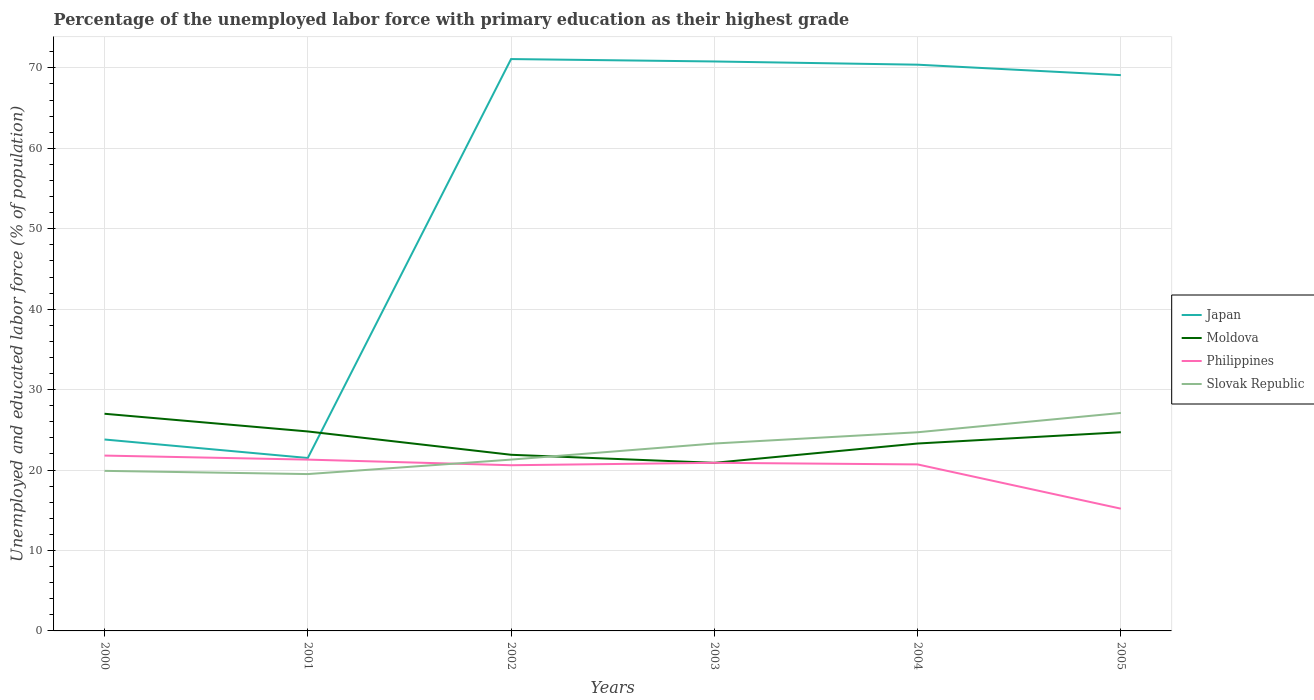How many different coloured lines are there?
Provide a succinct answer. 4. Does the line corresponding to Japan intersect with the line corresponding to Slovak Republic?
Provide a succinct answer. No. What is the total percentage of the unemployed labor force with primary education in Moldova in the graph?
Provide a short and direct response. 6.1. What is the difference between the highest and the second highest percentage of the unemployed labor force with primary education in Moldova?
Make the answer very short. 6.1. What is the difference between the highest and the lowest percentage of the unemployed labor force with primary education in Japan?
Offer a terse response. 4. Is the percentage of the unemployed labor force with primary education in Slovak Republic strictly greater than the percentage of the unemployed labor force with primary education in Moldova over the years?
Ensure brevity in your answer.  No. How many lines are there?
Give a very brief answer. 4. What is the difference between two consecutive major ticks on the Y-axis?
Give a very brief answer. 10. What is the title of the graph?
Offer a very short reply. Percentage of the unemployed labor force with primary education as their highest grade. What is the label or title of the X-axis?
Provide a succinct answer. Years. What is the label or title of the Y-axis?
Your answer should be very brief. Unemployed and educated labor force (% of population). What is the Unemployed and educated labor force (% of population) in Japan in 2000?
Your answer should be compact. 23.8. What is the Unemployed and educated labor force (% of population) of Moldova in 2000?
Keep it short and to the point. 27. What is the Unemployed and educated labor force (% of population) of Philippines in 2000?
Give a very brief answer. 21.8. What is the Unemployed and educated labor force (% of population) in Slovak Republic in 2000?
Offer a very short reply. 19.9. What is the Unemployed and educated labor force (% of population) in Moldova in 2001?
Offer a terse response. 24.8. What is the Unemployed and educated labor force (% of population) of Philippines in 2001?
Keep it short and to the point. 21.3. What is the Unemployed and educated labor force (% of population) of Slovak Republic in 2001?
Offer a terse response. 19.5. What is the Unemployed and educated labor force (% of population) in Japan in 2002?
Provide a succinct answer. 71.1. What is the Unemployed and educated labor force (% of population) in Moldova in 2002?
Make the answer very short. 21.9. What is the Unemployed and educated labor force (% of population) in Philippines in 2002?
Your answer should be compact. 20.6. What is the Unemployed and educated labor force (% of population) of Slovak Republic in 2002?
Offer a terse response. 21.3. What is the Unemployed and educated labor force (% of population) in Japan in 2003?
Ensure brevity in your answer.  70.8. What is the Unemployed and educated labor force (% of population) of Moldova in 2003?
Your response must be concise. 20.9. What is the Unemployed and educated labor force (% of population) in Philippines in 2003?
Make the answer very short. 20.9. What is the Unemployed and educated labor force (% of population) in Slovak Republic in 2003?
Your response must be concise. 23.3. What is the Unemployed and educated labor force (% of population) of Japan in 2004?
Your answer should be compact. 70.4. What is the Unemployed and educated labor force (% of population) of Moldova in 2004?
Make the answer very short. 23.3. What is the Unemployed and educated labor force (% of population) in Philippines in 2004?
Make the answer very short. 20.7. What is the Unemployed and educated labor force (% of population) in Slovak Republic in 2004?
Provide a succinct answer. 24.7. What is the Unemployed and educated labor force (% of population) of Japan in 2005?
Your response must be concise. 69.1. What is the Unemployed and educated labor force (% of population) in Moldova in 2005?
Give a very brief answer. 24.7. What is the Unemployed and educated labor force (% of population) in Philippines in 2005?
Give a very brief answer. 15.2. What is the Unemployed and educated labor force (% of population) in Slovak Republic in 2005?
Make the answer very short. 27.1. Across all years, what is the maximum Unemployed and educated labor force (% of population) in Japan?
Your answer should be compact. 71.1. Across all years, what is the maximum Unemployed and educated labor force (% of population) in Philippines?
Keep it short and to the point. 21.8. Across all years, what is the maximum Unemployed and educated labor force (% of population) in Slovak Republic?
Offer a very short reply. 27.1. Across all years, what is the minimum Unemployed and educated labor force (% of population) in Japan?
Ensure brevity in your answer.  21.5. Across all years, what is the minimum Unemployed and educated labor force (% of population) in Moldova?
Provide a succinct answer. 20.9. Across all years, what is the minimum Unemployed and educated labor force (% of population) in Philippines?
Your response must be concise. 15.2. What is the total Unemployed and educated labor force (% of population) in Japan in the graph?
Your answer should be very brief. 326.7. What is the total Unemployed and educated labor force (% of population) in Moldova in the graph?
Your answer should be very brief. 142.6. What is the total Unemployed and educated labor force (% of population) of Philippines in the graph?
Offer a terse response. 120.5. What is the total Unemployed and educated labor force (% of population) in Slovak Republic in the graph?
Provide a succinct answer. 135.8. What is the difference between the Unemployed and educated labor force (% of population) of Moldova in 2000 and that in 2001?
Offer a very short reply. 2.2. What is the difference between the Unemployed and educated labor force (% of population) of Philippines in 2000 and that in 2001?
Ensure brevity in your answer.  0.5. What is the difference between the Unemployed and educated labor force (% of population) of Japan in 2000 and that in 2002?
Keep it short and to the point. -47.3. What is the difference between the Unemployed and educated labor force (% of population) in Slovak Republic in 2000 and that in 2002?
Keep it short and to the point. -1.4. What is the difference between the Unemployed and educated labor force (% of population) in Japan in 2000 and that in 2003?
Provide a short and direct response. -47. What is the difference between the Unemployed and educated labor force (% of population) of Slovak Republic in 2000 and that in 2003?
Offer a very short reply. -3.4. What is the difference between the Unemployed and educated labor force (% of population) of Japan in 2000 and that in 2004?
Ensure brevity in your answer.  -46.6. What is the difference between the Unemployed and educated labor force (% of population) in Philippines in 2000 and that in 2004?
Provide a succinct answer. 1.1. What is the difference between the Unemployed and educated labor force (% of population) of Slovak Republic in 2000 and that in 2004?
Your answer should be compact. -4.8. What is the difference between the Unemployed and educated labor force (% of population) of Japan in 2000 and that in 2005?
Give a very brief answer. -45.3. What is the difference between the Unemployed and educated labor force (% of population) of Slovak Republic in 2000 and that in 2005?
Provide a succinct answer. -7.2. What is the difference between the Unemployed and educated labor force (% of population) of Japan in 2001 and that in 2002?
Give a very brief answer. -49.6. What is the difference between the Unemployed and educated labor force (% of population) in Japan in 2001 and that in 2003?
Provide a succinct answer. -49.3. What is the difference between the Unemployed and educated labor force (% of population) in Philippines in 2001 and that in 2003?
Keep it short and to the point. 0.4. What is the difference between the Unemployed and educated labor force (% of population) in Slovak Republic in 2001 and that in 2003?
Your response must be concise. -3.8. What is the difference between the Unemployed and educated labor force (% of population) of Japan in 2001 and that in 2004?
Provide a short and direct response. -48.9. What is the difference between the Unemployed and educated labor force (% of population) in Philippines in 2001 and that in 2004?
Keep it short and to the point. 0.6. What is the difference between the Unemployed and educated labor force (% of population) of Japan in 2001 and that in 2005?
Offer a terse response. -47.6. What is the difference between the Unemployed and educated labor force (% of population) in Moldova in 2001 and that in 2005?
Offer a terse response. 0.1. What is the difference between the Unemployed and educated labor force (% of population) in Philippines in 2001 and that in 2005?
Provide a short and direct response. 6.1. What is the difference between the Unemployed and educated labor force (% of population) of Japan in 2002 and that in 2003?
Your answer should be compact. 0.3. What is the difference between the Unemployed and educated labor force (% of population) of Slovak Republic in 2002 and that in 2003?
Your response must be concise. -2. What is the difference between the Unemployed and educated labor force (% of population) in Moldova in 2002 and that in 2004?
Offer a very short reply. -1.4. What is the difference between the Unemployed and educated labor force (% of population) in Slovak Republic in 2002 and that in 2004?
Provide a short and direct response. -3.4. What is the difference between the Unemployed and educated labor force (% of population) of Moldova in 2002 and that in 2005?
Provide a short and direct response. -2.8. What is the difference between the Unemployed and educated labor force (% of population) of Slovak Republic in 2002 and that in 2005?
Make the answer very short. -5.8. What is the difference between the Unemployed and educated labor force (% of population) of Japan in 2003 and that in 2004?
Your response must be concise. 0.4. What is the difference between the Unemployed and educated labor force (% of population) in Philippines in 2003 and that in 2004?
Make the answer very short. 0.2. What is the difference between the Unemployed and educated labor force (% of population) in Slovak Republic in 2003 and that in 2004?
Keep it short and to the point. -1.4. What is the difference between the Unemployed and educated labor force (% of population) of Japan in 2003 and that in 2005?
Provide a succinct answer. 1.7. What is the difference between the Unemployed and educated labor force (% of population) in Moldova in 2003 and that in 2005?
Your answer should be compact. -3.8. What is the difference between the Unemployed and educated labor force (% of population) in Philippines in 2003 and that in 2005?
Offer a very short reply. 5.7. What is the difference between the Unemployed and educated labor force (% of population) of Slovak Republic in 2003 and that in 2005?
Offer a very short reply. -3.8. What is the difference between the Unemployed and educated labor force (% of population) in Japan in 2004 and that in 2005?
Keep it short and to the point. 1.3. What is the difference between the Unemployed and educated labor force (% of population) in Slovak Republic in 2004 and that in 2005?
Offer a terse response. -2.4. What is the difference between the Unemployed and educated labor force (% of population) in Japan in 2000 and the Unemployed and educated labor force (% of population) in Philippines in 2001?
Make the answer very short. 2.5. What is the difference between the Unemployed and educated labor force (% of population) of Moldova in 2000 and the Unemployed and educated labor force (% of population) of Philippines in 2001?
Offer a very short reply. 5.7. What is the difference between the Unemployed and educated labor force (% of population) of Japan in 2000 and the Unemployed and educated labor force (% of population) of Moldova in 2002?
Your answer should be very brief. 1.9. What is the difference between the Unemployed and educated labor force (% of population) of Japan in 2000 and the Unemployed and educated labor force (% of population) of Philippines in 2002?
Ensure brevity in your answer.  3.2. What is the difference between the Unemployed and educated labor force (% of population) in Philippines in 2000 and the Unemployed and educated labor force (% of population) in Slovak Republic in 2002?
Provide a succinct answer. 0.5. What is the difference between the Unemployed and educated labor force (% of population) of Japan in 2000 and the Unemployed and educated labor force (% of population) of Moldova in 2003?
Your answer should be very brief. 2.9. What is the difference between the Unemployed and educated labor force (% of population) in Japan in 2000 and the Unemployed and educated labor force (% of population) in Slovak Republic in 2003?
Offer a very short reply. 0.5. What is the difference between the Unemployed and educated labor force (% of population) of Moldova in 2000 and the Unemployed and educated labor force (% of population) of Slovak Republic in 2003?
Offer a very short reply. 3.7. What is the difference between the Unemployed and educated labor force (% of population) in Japan in 2000 and the Unemployed and educated labor force (% of population) in Moldova in 2004?
Make the answer very short. 0.5. What is the difference between the Unemployed and educated labor force (% of population) in Japan in 2000 and the Unemployed and educated labor force (% of population) in Slovak Republic in 2004?
Your answer should be compact. -0.9. What is the difference between the Unemployed and educated labor force (% of population) in Moldova in 2000 and the Unemployed and educated labor force (% of population) in Slovak Republic in 2004?
Make the answer very short. 2.3. What is the difference between the Unemployed and educated labor force (% of population) of Japan in 2000 and the Unemployed and educated labor force (% of population) of Moldova in 2005?
Your response must be concise. -0.9. What is the difference between the Unemployed and educated labor force (% of population) in Japan in 2000 and the Unemployed and educated labor force (% of population) in Philippines in 2005?
Your answer should be very brief. 8.6. What is the difference between the Unemployed and educated labor force (% of population) in Moldova in 2000 and the Unemployed and educated labor force (% of population) in Philippines in 2005?
Your answer should be very brief. 11.8. What is the difference between the Unemployed and educated labor force (% of population) of Japan in 2001 and the Unemployed and educated labor force (% of population) of Moldova in 2002?
Your answer should be very brief. -0.4. What is the difference between the Unemployed and educated labor force (% of population) of Japan in 2001 and the Unemployed and educated labor force (% of population) of Philippines in 2002?
Make the answer very short. 0.9. What is the difference between the Unemployed and educated labor force (% of population) of Japan in 2001 and the Unemployed and educated labor force (% of population) of Slovak Republic in 2002?
Provide a short and direct response. 0.2. What is the difference between the Unemployed and educated labor force (% of population) of Moldova in 2001 and the Unemployed and educated labor force (% of population) of Philippines in 2002?
Ensure brevity in your answer.  4.2. What is the difference between the Unemployed and educated labor force (% of population) of Japan in 2001 and the Unemployed and educated labor force (% of population) of Moldova in 2003?
Your answer should be compact. 0.6. What is the difference between the Unemployed and educated labor force (% of population) in Japan in 2001 and the Unemployed and educated labor force (% of population) in Philippines in 2003?
Ensure brevity in your answer.  0.6. What is the difference between the Unemployed and educated labor force (% of population) of Japan in 2001 and the Unemployed and educated labor force (% of population) of Slovak Republic in 2003?
Your answer should be compact. -1.8. What is the difference between the Unemployed and educated labor force (% of population) of Moldova in 2001 and the Unemployed and educated labor force (% of population) of Philippines in 2003?
Offer a terse response. 3.9. What is the difference between the Unemployed and educated labor force (% of population) of Japan in 2001 and the Unemployed and educated labor force (% of population) of Philippines in 2004?
Your answer should be very brief. 0.8. What is the difference between the Unemployed and educated labor force (% of population) in Japan in 2001 and the Unemployed and educated labor force (% of population) in Moldova in 2005?
Provide a succinct answer. -3.2. What is the difference between the Unemployed and educated labor force (% of population) of Japan in 2001 and the Unemployed and educated labor force (% of population) of Philippines in 2005?
Offer a terse response. 6.3. What is the difference between the Unemployed and educated labor force (% of population) in Japan in 2001 and the Unemployed and educated labor force (% of population) in Slovak Republic in 2005?
Give a very brief answer. -5.6. What is the difference between the Unemployed and educated labor force (% of population) in Moldova in 2001 and the Unemployed and educated labor force (% of population) in Philippines in 2005?
Make the answer very short. 9.6. What is the difference between the Unemployed and educated labor force (% of population) of Moldova in 2001 and the Unemployed and educated labor force (% of population) of Slovak Republic in 2005?
Offer a terse response. -2.3. What is the difference between the Unemployed and educated labor force (% of population) of Philippines in 2001 and the Unemployed and educated labor force (% of population) of Slovak Republic in 2005?
Make the answer very short. -5.8. What is the difference between the Unemployed and educated labor force (% of population) of Japan in 2002 and the Unemployed and educated labor force (% of population) of Moldova in 2003?
Your answer should be compact. 50.2. What is the difference between the Unemployed and educated labor force (% of population) of Japan in 2002 and the Unemployed and educated labor force (% of population) of Philippines in 2003?
Make the answer very short. 50.2. What is the difference between the Unemployed and educated labor force (% of population) of Japan in 2002 and the Unemployed and educated labor force (% of population) of Slovak Republic in 2003?
Your answer should be very brief. 47.8. What is the difference between the Unemployed and educated labor force (% of population) in Japan in 2002 and the Unemployed and educated labor force (% of population) in Moldova in 2004?
Offer a terse response. 47.8. What is the difference between the Unemployed and educated labor force (% of population) in Japan in 2002 and the Unemployed and educated labor force (% of population) in Philippines in 2004?
Provide a succinct answer. 50.4. What is the difference between the Unemployed and educated labor force (% of population) in Japan in 2002 and the Unemployed and educated labor force (% of population) in Slovak Republic in 2004?
Make the answer very short. 46.4. What is the difference between the Unemployed and educated labor force (% of population) of Moldova in 2002 and the Unemployed and educated labor force (% of population) of Philippines in 2004?
Make the answer very short. 1.2. What is the difference between the Unemployed and educated labor force (% of population) of Moldova in 2002 and the Unemployed and educated labor force (% of population) of Slovak Republic in 2004?
Provide a succinct answer. -2.8. What is the difference between the Unemployed and educated labor force (% of population) in Philippines in 2002 and the Unemployed and educated labor force (% of population) in Slovak Republic in 2004?
Your answer should be compact. -4.1. What is the difference between the Unemployed and educated labor force (% of population) of Japan in 2002 and the Unemployed and educated labor force (% of population) of Moldova in 2005?
Make the answer very short. 46.4. What is the difference between the Unemployed and educated labor force (% of population) in Japan in 2002 and the Unemployed and educated labor force (% of population) in Philippines in 2005?
Give a very brief answer. 55.9. What is the difference between the Unemployed and educated labor force (% of population) of Moldova in 2002 and the Unemployed and educated labor force (% of population) of Slovak Republic in 2005?
Your answer should be very brief. -5.2. What is the difference between the Unemployed and educated labor force (% of population) of Philippines in 2002 and the Unemployed and educated labor force (% of population) of Slovak Republic in 2005?
Make the answer very short. -6.5. What is the difference between the Unemployed and educated labor force (% of population) in Japan in 2003 and the Unemployed and educated labor force (% of population) in Moldova in 2004?
Ensure brevity in your answer.  47.5. What is the difference between the Unemployed and educated labor force (% of population) in Japan in 2003 and the Unemployed and educated labor force (% of population) in Philippines in 2004?
Keep it short and to the point. 50.1. What is the difference between the Unemployed and educated labor force (% of population) in Japan in 2003 and the Unemployed and educated labor force (% of population) in Slovak Republic in 2004?
Your answer should be compact. 46.1. What is the difference between the Unemployed and educated labor force (% of population) of Moldova in 2003 and the Unemployed and educated labor force (% of population) of Philippines in 2004?
Your response must be concise. 0.2. What is the difference between the Unemployed and educated labor force (% of population) of Philippines in 2003 and the Unemployed and educated labor force (% of population) of Slovak Republic in 2004?
Your response must be concise. -3.8. What is the difference between the Unemployed and educated labor force (% of population) of Japan in 2003 and the Unemployed and educated labor force (% of population) of Moldova in 2005?
Keep it short and to the point. 46.1. What is the difference between the Unemployed and educated labor force (% of population) in Japan in 2003 and the Unemployed and educated labor force (% of population) in Philippines in 2005?
Ensure brevity in your answer.  55.6. What is the difference between the Unemployed and educated labor force (% of population) of Japan in 2003 and the Unemployed and educated labor force (% of population) of Slovak Republic in 2005?
Offer a terse response. 43.7. What is the difference between the Unemployed and educated labor force (% of population) of Moldova in 2003 and the Unemployed and educated labor force (% of population) of Slovak Republic in 2005?
Keep it short and to the point. -6.2. What is the difference between the Unemployed and educated labor force (% of population) of Japan in 2004 and the Unemployed and educated labor force (% of population) of Moldova in 2005?
Provide a succinct answer. 45.7. What is the difference between the Unemployed and educated labor force (% of population) of Japan in 2004 and the Unemployed and educated labor force (% of population) of Philippines in 2005?
Make the answer very short. 55.2. What is the difference between the Unemployed and educated labor force (% of population) in Japan in 2004 and the Unemployed and educated labor force (% of population) in Slovak Republic in 2005?
Give a very brief answer. 43.3. What is the average Unemployed and educated labor force (% of population) of Japan per year?
Make the answer very short. 54.45. What is the average Unemployed and educated labor force (% of population) of Moldova per year?
Ensure brevity in your answer.  23.77. What is the average Unemployed and educated labor force (% of population) of Philippines per year?
Your response must be concise. 20.08. What is the average Unemployed and educated labor force (% of population) in Slovak Republic per year?
Provide a succinct answer. 22.63. In the year 2000, what is the difference between the Unemployed and educated labor force (% of population) in Japan and Unemployed and educated labor force (% of population) in Moldova?
Provide a succinct answer. -3.2. In the year 2000, what is the difference between the Unemployed and educated labor force (% of population) of Japan and Unemployed and educated labor force (% of population) of Philippines?
Provide a succinct answer. 2. In the year 2000, what is the difference between the Unemployed and educated labor force (% of population) of Moldova and Unemployed and educated labor force (% of population) of Slovak Republic?
Provide a short and direct response. 7.1. In the year 2000, what is the difference between the Unemployed and educated labor force (% of population) of Philippines and Unemployed and educated labor force (% of population) of Slovak Republic?
Your answer should be compact. 1.9. In the year 2001, what is the difference between the Unemployed and educated labor force (% of population) of Japan and Unemployed and educated labor force (% of population) of Philippines?
Your answer should be very brief. 0.2. In the year 2001, what is the difference between the Unemployed and educated labor force (% of population) in Moldova and Unemployed and educated labor force (% of population) in Philippines?
Make the answer very short. 3.5. In the year 2001, what is the difference between the Unemployed and educated labor force (% of population) of Philippines and Unemployed and educated labor force (% of population) of Slovak Republic?
Ensure brevity in your answer.  1.8. In the year 2002, what is the difference between the Unemployed and educated labor force (% of population) in Japan and Unemployed and educated labor force (% of population) in Moldova?
Your answer should be compact. 49.2. In the year 2002, what is the difference between the Unemployed and educated labor force (% of population) of Japan and Unemployed and educated labor force (% of population) of Philippines?
Your response must be concise. 50.5. In the year 2002, what is the difference between the Unemployed and educated labor force (% of population) in Japan and Unemployed and educated labor force (% of population) in Slovak Republic?
Give a very brief answer. 49.8. In the year 2003, what is the difference between the Unemployed and educated labor force (% of population) of Japan and Unemployed and educated labor force (% of population) of Moldova?
Provide a succinct answer. 49.9. In the year 2003, what is the difference between the Unemployed and educated labor force (% of population) of Japan and Unemployed and educated labor force (% of population) of Philippines?
Your response must be concise. 49.9. In the year 2003, what is the difference between the Unemployed and educated labor force (% of population) in Japan and Unemployed and educated labor force (% of population) in Slovak Republic?
Your response must be concise. 47.5. In the year 2003, what is the difference between the Unemployed and educated labor force (% of population) in Moldova and Unemployed and educated labor force (% of population) in Slovak Republic?
Provide a short and direct response. -2.4. In the year 2004, what is the difference between the Unemployed and educated labor force (% of population) in Japan and Unemployed and educated labor force (% of population) in Moldova?
Offer a very short reply. 47.1. In the year 2004, what is the difference between the Unemployed and educated labor force (% of population) of Japan and Unemployed and educated labor force (% of population) of Philippines?
Your response must be concise. 49.7. In the year 2004, what is the difference between the Unemployed and educated labor force (% of population) in Japan and Unemployed and educated labor force (% of population) in Slovak Republic?
Ensure brevity in your answer.  45.7. In the year 2004, what is the difference between the Unemployed and educated labor force (% of population) in Moldova and Unemployed and educated labor force (% of population) in Slovak Republic?
Your answer should be very brief. -1.4. In the year 2005, what is the difference between the Unemployed and educated labor force (% of population) in Japan and Unemployed and educated labor force (% of population) in Moldova?
Your answer should be very brief. 44.4. In the year 2005, what is the difference between the Unemployed and educated labor force (% of population) in Japan and Unemployed and educated labor force (% of population) in Philippines?
Provide a short and direct response. 53.9. In the year 2005, what is the difference between the Unemployed and educated labor force (% of population) in Japan and Unemployed and educated labor force (% of population) in Slovak Republic?
Provide a succinct answer. 42. What is the ratio of the Unemployed and educated labor force (% of population) in Japan in 2000 to that in 2001?
Provide a short and direct response. 1.11. What is the ratio of the Unemployed and educated labor force (% of population) of Moldova in 2000 to that in 2001?
Offer a terse response. 1.09. What is the ratio of the Unemployed and educated labor force (% of population) in Philippines in 2000 to that in 2001?
Offer a very short reply. 1.02. What is the ratio of the Unemployed and educated labor force (% of population) of Slovak Republic in 2000 to that in 2001?
Offer a very short reply. 1.02. What is the ratio of the Unemployed and educated labor force (% of population) of Japan in 2000 to that in 2002?
Offer a very short reply. 0.33. What is the ratio of the Unemployed and educated labor force (% of population) of Moldova in 2000 to that in 2002?
Your answer should be compact. 1.23. What is the ratio of the Unemployed and educated labor force (% of population) in Philippines in 2000 to that in 2002?
Provide a short and direct response. 1.06. What is the ratio of the Unemployed and educated labor force (% of population) in Slovak Republic in 2000 to that in 2002?
Your answer should be compact. 0.93. What is the ratio of the Unemployed and educated labor force (% of population) in Japan in 2000 to that in 2003?
Ensure brevity in your answer.  0.34. What is the ratio of the Unemployed and educated labor force (% of population) of Moldova in 2000 to that in 2003?
Provide a succinct answer. 1.29. What is the ratio of the Unemployed and educated labor force (% of population) in Philippines in 2000 to that in 2003?
Provide a short and direct response. 1.04. What is the ratio of the Unemployed and educated labor force (% of population) of Slovak Republic in 2000 to that in 2003?
Offer a very short reply. 0.85. What is the ratio of the Unemployed and educated labor force (% of population) in Japan in 2000 to that in 2004?
Give a very brief answer. 0.34. What is the ratio of the Unemployed and educated labor force (% of population) in Moldova in 2000 to that in 2004?
Your answer should be very brief. 1.16. What is the ratio of the Unemployed and educated labor force (% of population) of Philippines in 2000 to that in 2004?
Make the answer very short. 1.05. What is the ratio of the Unemployed and educated labor force (% of population) in Slovak Republic in 2000 to that in 2004?
Give a very brief answer. 0.81. What is the ratio of the Unemployed and educated labor force (% of population) in Japan in 2000 to that in 2005?
Offer a terse response. 0.34. What is the ratio of the Unemployed and educated labor force (% of population) of Moldova in 2000 to that in 2005?
Your answer should be compact. 1.09. What is the ratio of the Unemployed and educated labor force (% of population) of Philippines in 2000 to that in 2005?
Your answer should be very brief. 1.43. What is the ratio of the Unemployed and educated labor force (% of population) of Slovak Republic in 2000 to that in 2005?
Make the answer very short. 0.73. What is the ratio of the Unemployed and educated labor force (% of population) of Japan in 2001 to that in 2002?
Keep it short and to the point. 0.3. What is the ratio of the Unemployed and educated labor force (% of population) of Moldova in 2001 to that in 2002?
Your response must be concise. 1.13. What is the ratio of the Unemployed and educated labor force (% of population) in Philippines in 2001 to that in 2002?
Make the answer very short. 1.03. What is the ratio of the Unemployed and educated labor force (% of population) of Slovak Republic in 2001 to that in 2002?
Provide a succinct answer. 0.92. What is the ratio of the Unemployed and educated labor force (% of population) of Japan in 2001 to that in 2003?
Offer a very short reply. 0.3. What is the ratio of the Unemployed and educated labor force (% of population) in Moldova in 2001 to that in 2003?
Offer a very short reply. 1.19. What is the ratio of the Unemployed and educated labor force (% of population) of Philippines in 2001 to that in 2003?
Your response must be concise. 1.02. What is the ratio of the Unemployed and educated labor force (% of population) of Slovak Republic in 2001 to that in 2003?
Provide a short and direct response. 0.84. What is the ratio of the Unemployed and educated labor force (% of population) in Japan in 2001 to that in 2004?
Offer a terse response. 0.31. What is the ratio of the Unemployed and educated labor force (% of population) of Moldova in 2001 to that in 2004?
Your answer should be very brief. 1.06. What is the ratio of the Unemployed and educated labor force (% of population) in Philippines in 2001 to that in 2004?
Offer a terse response. 1.03. What is the ratio of the Unemployed and educated labor force (% of population) of Slovak Republic in 2001 to that in 2004?
Your answer should be very brief. 0.79. What is the ratio of the Unemployed and educated labor force (% of population) in Japan in 2001 to that in 2005?
Offer a terse response. 0.31. What is the ratio of the Unemployed and educated labor force (% of population) in Philippines in 2001 to that in 2005?
Keep it short and to the point. 1.4. What is the ratio of the Unemployed and educated labor force (% of population) in Slovak Republic in 2001 to that in 2005?
Your answer should be very brief. 0.72. What is the ratio of the Unemployed and educated labor force (% of population) in Japan in 2002 to that in 2003?
Ensure brevity in your answer.  1. What is the ratio of the Unemployed and educated labor force (% of population) in Moldova in 2002 to that in 2003?
Give a very brief answer. 1.05. What is the ratio of the Unemployed and educated labor force (% of population) in Philippines in 2002 to that in 2003?
Your answer should be very brief. 0.99. What is the ratio of the Unemployed and educated labor force (% of population) in Slovak Republic in 2002 to that in 2003?
Your answer should be compact. 0.91. What is the ratio of the Unemployed and educated labor force (% of population) of Japan in 2002 to that in 2004?
Provide a succinct answer. 1.01. What is the ratio of the Unemployed and educated labor force (% of population) of Moldova in 2002 to that in 2004?
Give a very brief answer. 0.94. What is the ratio of the Unemployed and educated labor force (% of population) of Philippines in 2002 to that in 2004?
Offer a very short reply. 1. What is the ratio of the Unemployed and educated labor force (% of population) in Slovak Republic in 2002 to that in 2004?
Keep it short and to the point. 0.86. What is the ratio of the Unemployed and educated labor force (% of population) of Japan in 2002 to that in 2005?
Make the answer very short. 1.03. What is the ratio of the Unemployed and educated labor force (% of population) of Moldova in 2002 to that in 2005?
Your answer should be compact. 0.89. What is the ratio of the Unemployed and educated labor force (% of population) of Philippines in 2002 to that in 2005?
Keep it short and to the point. 1.36. What is the ratio of the Unemployed and educated labor force (% of population) in Slovak Republic in 2002 to that in 2005?
Make the answer very short. 0.79. What is the ratio of the Unemployed and educated labor force (% of population) in Japan in 2003 to that in 2004?
Your response must be concise. 1.01. What is the ratio of the Unemployed and educated labor force (% of population) in Moldova in 2003 to that in 2004?
Ensure brevity in your answer.  0.9. What is the ratio of the Unemployed and educated labor force (% of population) in Philippines in 2003 to that in 2004?
Offer a very short reply. 1.01. What is the ratio of the Unemployed and educated labor force (% of population) in Slovak Republic in 2003 to that in 2004?
Offer a very short reply. 0.94. What is the ratio of the Unemployed and educated labor force (% of population) in Japan in 2003 to that in 2005?
Your response must be concise. 1.02. What is the ratio of the Unemployed and educated labor force (% of population) in Moldova in 2003 to that in 2005?
Ensure brevity in your answer.  0.85. What is the ratio of the Unemployed and educated labor force (% of population) in Philippines in 2003 to that in 2005?
Ensure brevity in your answer.  1.38. What is the ratio of the Unemployed and educated labor force (% of population) in Slovak Republic in 2003 to that in 2005?
Your answer should be very brief. 0.86. What is the ratio of the Unemployed and educated labor force (% of population) of Japan in 2004 to that in 2005?
Your answer should be very brief. 1.02. What is the ratio of the Unemployed and educated labor force (% of population) of Moldova in 2004 to that in 2005?
Make the answer very short. 0.94. What is the ratio of the Unemployed and educated labor force (% of population) in Philippines in 2004 to that in 2005?
Offer a very short reply. 1.36. What is the ratio of the Unemployed and educated labor force (% of population) in Slovak Republic in 2004 to that in 2005?
Offer a very short reply. 0.91. What is the difference between the highest and the second highest Unemployed and educated labor force (% of population) of Philippines?
Offer a very short reply. 0.5. What is the difference between the highest and the lowest Unemployed and educated labor force (% of population) of Japan?
Provide a succinct answer. 49.6. What is the difference between the highest and the lowest Unemployed and educated labor force (% of population) of Moldova?
Ensure brevity in your answer.  6.1. What is the difference between the highest and the lowest Unemployed and educated labor force (% of population) in Slovak Republic?
Your response must be concise. 7.6. 